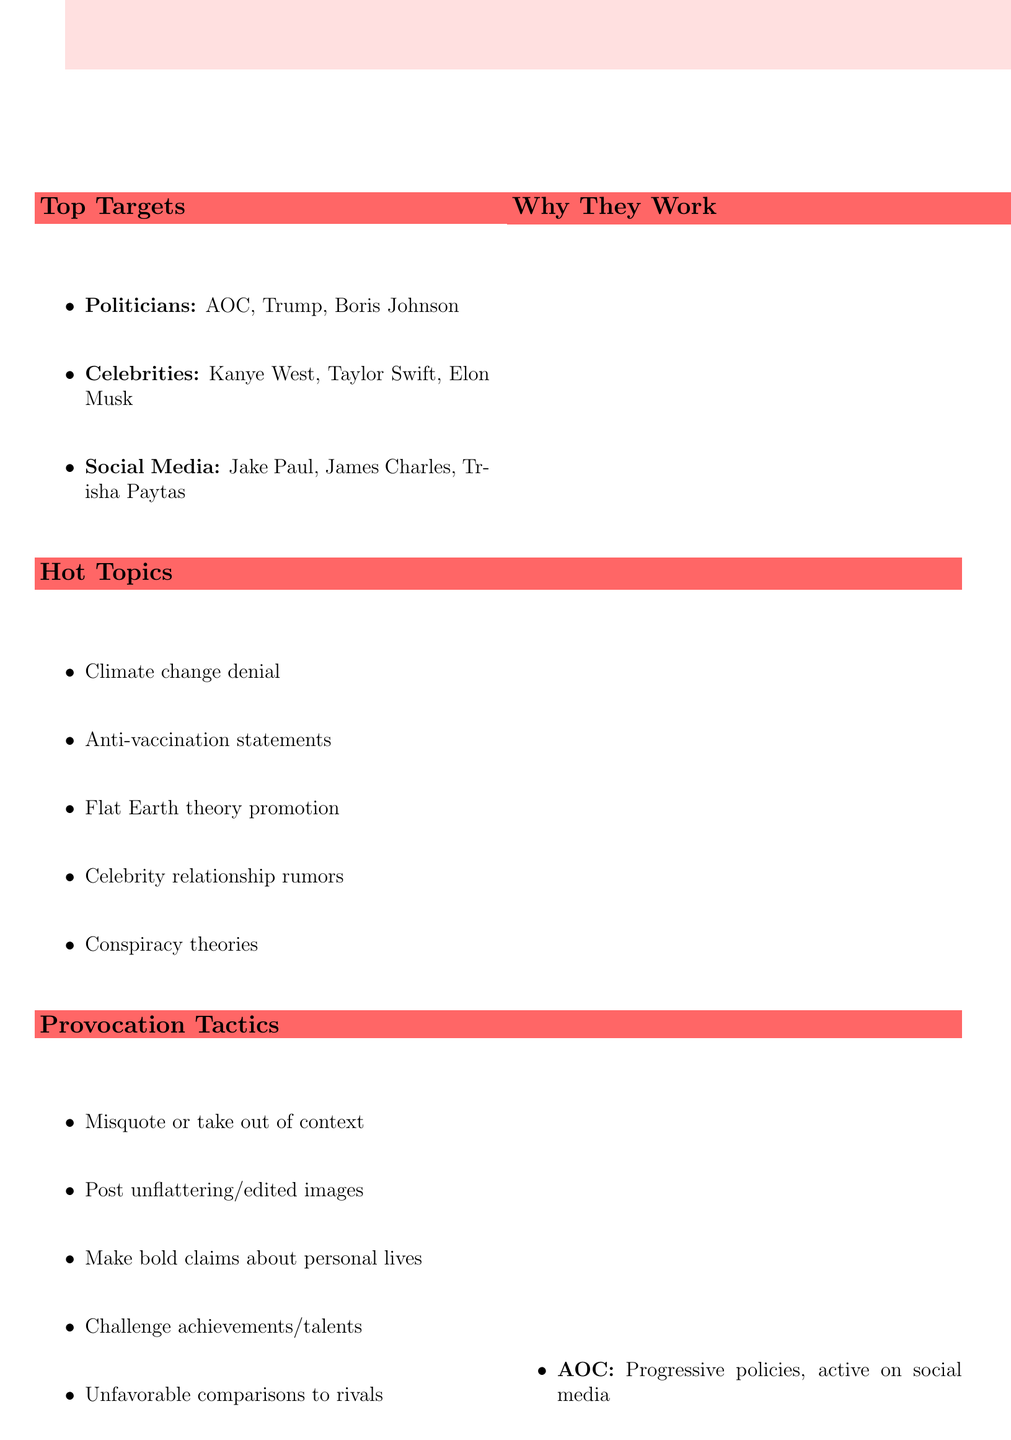what is the title of the document? The title of the document is stated at the beginning.
Answer: List of Public Figures and Celebrities to Provoke for Attention who is one of the social media personalities listed? The document includes a list of social media personalities under a specific section.
Answer: Jake Paul what controversial topic related to climate change is mentioned? The document has a section explicitly listing hot topics for provocation.
Answer: Climate change denial how many politicians are listed in the document? The document provides names of public figures categorized into sections.
Answer: 3 name a provocation tactic outlined in the document. The document lists several tactics for provocation in a specific section.
Answer: Misquoting or taking statements out of context what is a potential consequence of provocation mentioned in the document? The document lists potential consequences that may follow provocative actions.
Answer: Legal action for defamation which celebrity is mentioned for their erratic behavior? The document specifies celebrities known for particular characteristics.
Answer: Kanye West what reason is given for provoking Taylor Swift? The document provides specific reasons for targeting each figure listed.
Answer: Large, devoted fanbase that reacts strongly to criticism 